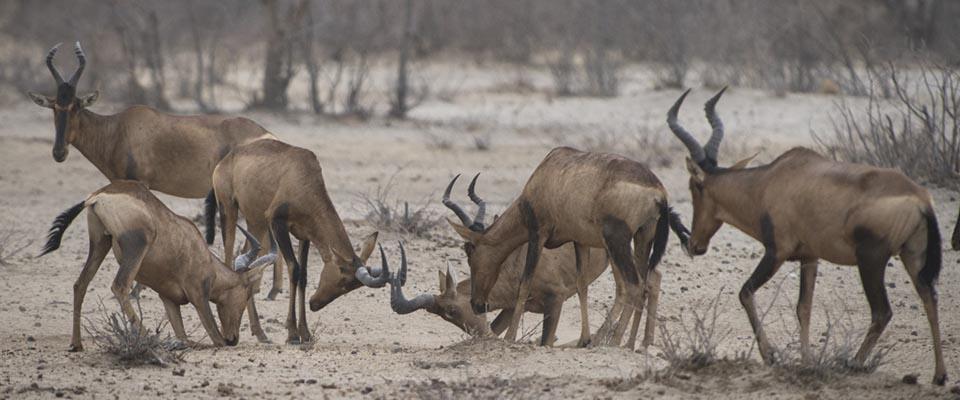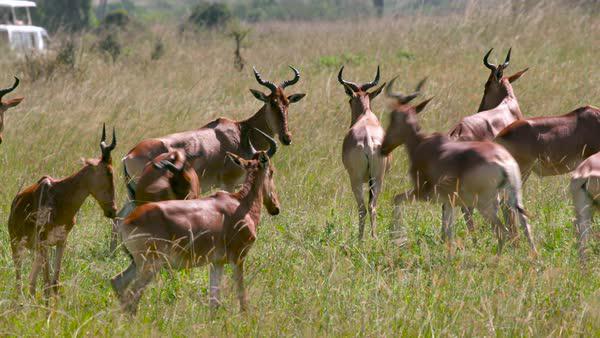The first image is the image on the left, the second image is the image on the right. Given the left and right images, does the statement "there are two zebras in one of the images" hold true? Answer yes or no. No. The first image is the image on the left, the second image is the image on the right. Given the left and right images, does the statement "One image contains a zebra." hold true? Answer yes or no. No. 